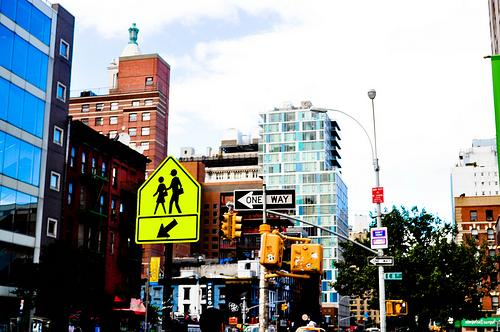How many traffic signals and pedestrian crossing signs can you find in the image? There are 4 traffic signals and 2 pedestrian crossing signs in the image. Describe the architecture and the colors of the buildings in the image. The buildings include a skyscraper with glass panels and square windows, an older building with small windows and fire escapes, a blue and white building with terraces, and a red brick and white building of different heights. Mention the variety of signs present in the image, including their color and purpose. The image includes a yellow school crossing sign, black and white one-way signs, a blurry green street sign, a crosswalk sign, a yellow traffic sign with a black arrow and figures, red "do not walk" signs, and various pedestrian crossing signs. Count the number of street signs in the image and describe their colors. There are 10 street signs, including yellow, black and white, green, and red signs. What type of environment does the image portray and what are the main objects present in it? The image portrays an urban environment with skyscrapers, older brick buildings, street signs, traffic lights, streetlights, a taxi cab, and trees on the sides. What is the main mode of transportation depicted in this image? The main mode of transportation depicted is a yellow taxi. Identify and describe the main colors present in the image. Predominant colors in the image are yellow, black, white, blue, red, and green, present in various signs, buildings, streetlights, and the sky. Provide an overall description of the image's street scene. The image depicts a bustling city street scene, featuring buildings of different architectural styles, various traffic signs, streetlights, and traffic signals, a yellow taxi, and greenery from trees. What natural elements can you see in the image and where are they located? There are trees across the street on the right, behind the streetlight, and a large tree blocking the view down the street. There is a white cloud against a gray sky and a blue sky above heavy white clouds. Describe the unique elements on the lamp posts and their colors. The lamp posts have a green street sign, red signs, and silver poles with lights, signs, and traffic signals. Can you spot the red fire hydrant next to the black and white one way sign? There is no fire hydrant in the list of objects in the image. Depict which buildings are in the foreground of the image. A red brick building, a blue and white building, an older building with small windows and fire escapes, and a building with a red canopy. Is there any do not walk sign in the image? If yes, how many? Yes, there are 3 do not walk signs. Can you find a taxi cab in the image? If yes, what color is it? Yes, there is a yellow taxi cab. What are the colors visible in the sky? Gray and white Does any of the buildings have a green awning?  Yes, a building on the right has a green awning. Based on the image, are there any defects? There is a blurry green street sign. Point out the pedestrian crossing sign in the image. yellow school crossing sign X:137 Y:156 Width:62 Height:62 Find the purple umbrella held by the person standing near the yellow school crossing sign. There is no person with a purple umbrella in the list of objects in the image. Mention any unusual or unexpected object in the image. There is nothing unusual or unexpected in the image. What are the interactions between the objects in the image? Traffic lights control the flow of vehicles, street signs guide pedestrians and drivers, buildings form the streetscape. Describe the emotions that the image may evoke. Urban life, busy, daytime, diverse architecture Identify the building with red canopy. red canopy of building X:117 Y:296 Width:24 Height:24 Are there any clouds in the sky? Yes, there is a white cloud against a gray sky. Identify the color of the buildings' facades in the image. Red, blue, white, yellow, brick, and glass. Count how many black and white one way street signs are there in the image. There are 3 one way street signs. Describe the color of the street lights. The street lights are yellow. Which building's windows have glass panels and square windows? The front of a skyscraper has glass panels and square windows. Count the number of electric traffic signals in the image. There are 3 electric traffic signals. What type of street sign is yellow and black? The yellow and black street sign is a school crossing sign with an arrow. Locate the pedistrian light in the image. pedistrian light X:377 Y:298 Width:33 Height:33 Is there a dog playing near the green awning on the building on the right? There is no dog mentioned in the list of objects in the image. Notice how the hot air balloon is floating high above the red brick building. There is no hot air balloon in the list of objects in the image. Please list all the tall objects in the image. A street lamp, a skyscraper, a tall blue building, and tree across the street. Where is the large graffiti artwork on the side of the blue and white building with terraces on upper floors? There is no graffiti artwork mentioned in the list of objects in the image. See the flock of birds flying above the heavy white clouds in the sky. There is no flock of birds in the list of objects in the image. 